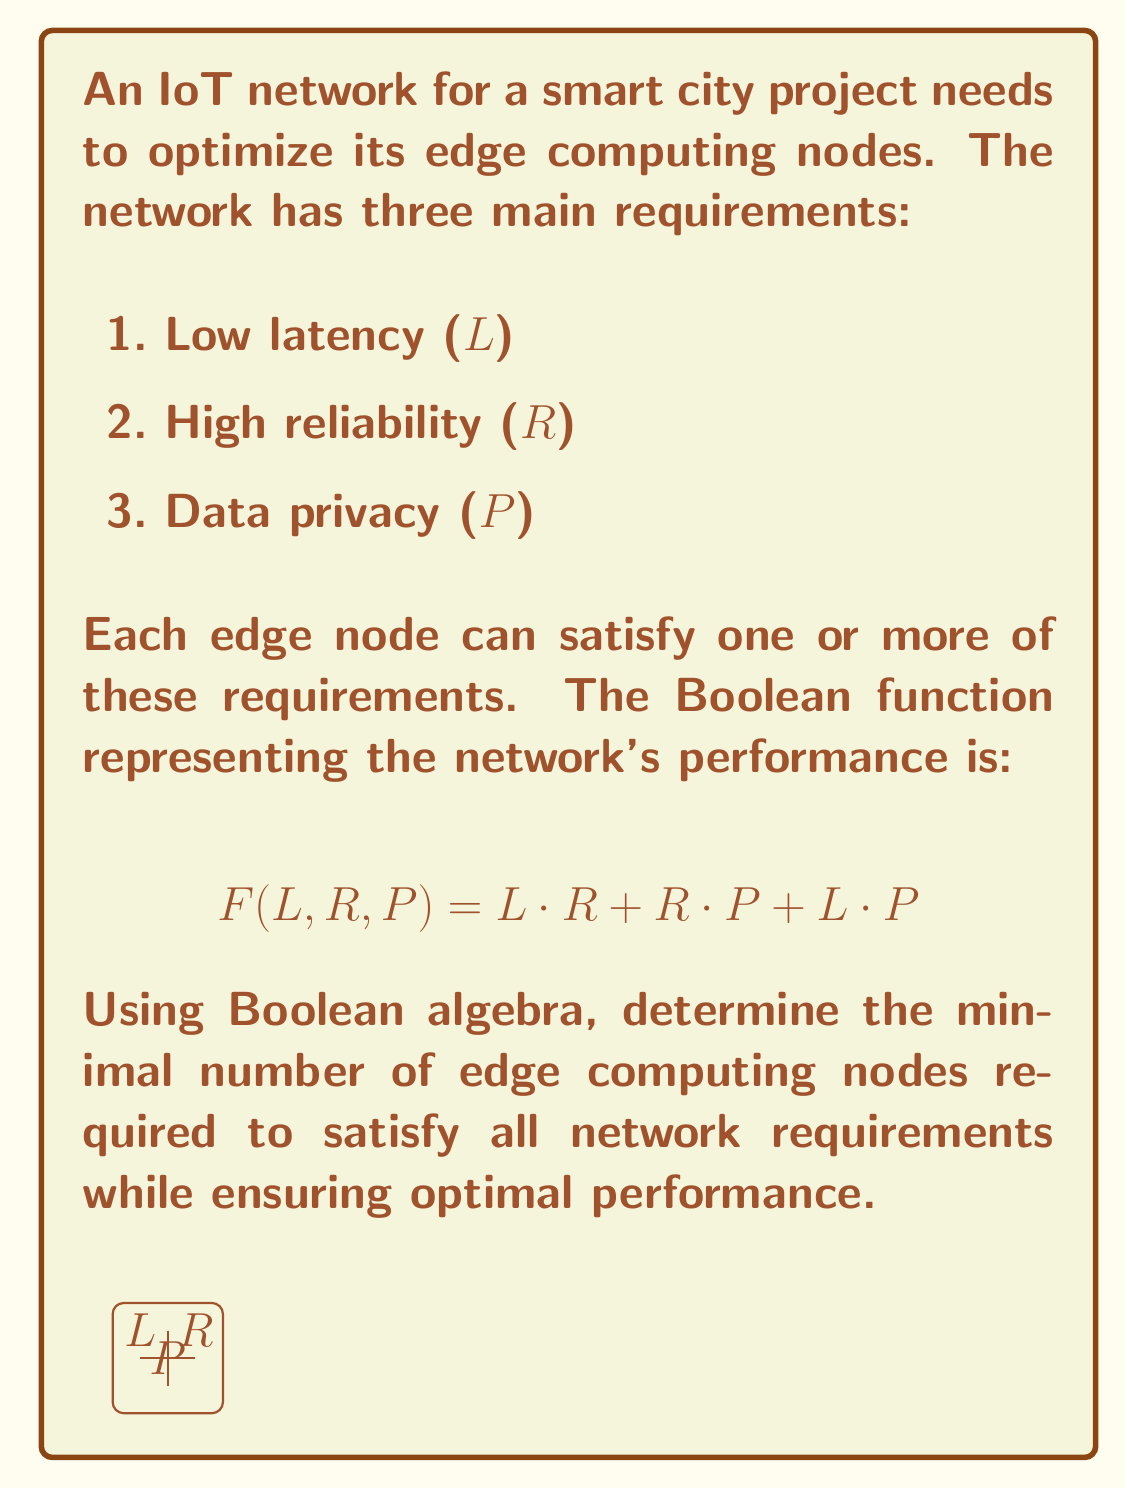Solve this math problem. To solve this problem, we'll use Boolean algebra to simplify the given function and determine the minimal form:

1. Start with the given function:
   $$ F(L, R, P) = L \cdot R + R \cdot P + L \cdot P $$

2. Apply the distributive law:
   $$ F(L, R, P) = L \cdot R + P \cdot (R + L) $$

3. The term $(R + L)$ can be factored out:
   $$ F(L, R, P) = (L + P) \cdot (R + P) $$

4. This is the minimal form of the function, known as the product of sums.

5. Each term in the product represents a necessary condition for the network's optimal performance:
   - $(L + P)$: Either low latency or data privacy must be satisfied
   - $(R + P)$: Either high reliability or data privacy must be satisfied

6. To satisfy both conditions with the minimum number of nodes, we need to choose the variable that appears in both terms, which is $P$ (data privacy).

7. By selecting a node that satisfies data privacy $(P)$, we automatically satisfy both terms in the minimal form.

8. However, this alone doesn't satisfy all three original requirements $(L, R, P)$. We need at least one more node to cover either $L$ or $R$.

Therefore, the minimal number of edge computing nodes required is 2:
1. One node satisfying data privacy $(P)$
2. One node satisfying either low latency $(L)$ or high reliability $(R)$
Answer: 2 nodes 